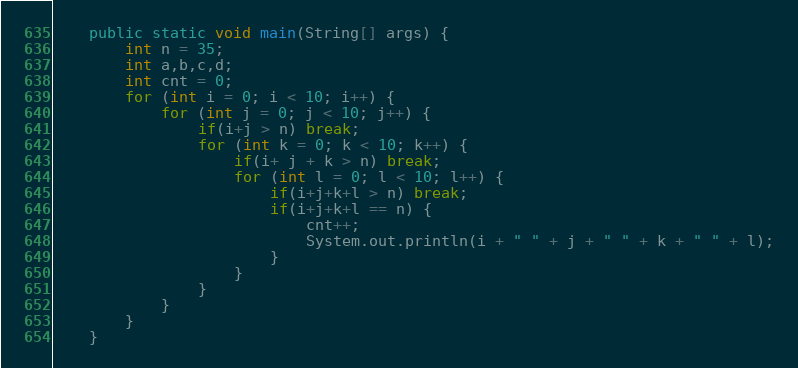Convert code to text. <code><loc_0><loc_0><loc_500><loc_500><_Java_>	public static void main(String[] args) {
		int n = 35;
		int a,b,c,d;
		int cnt = 0;
		for (int i = 0; i < 10; i++) {
			for (int j = 0; j < 10; j++) {
				if(i+j > n) break;
				for (int k = 0; k < 10; k++) {
					if(i+ j + k > n) break;
					for (int l = 0; l < 10; l++) {
						if(i+j+k+l > n) break;
						if(i+j+k+l == n) {
							cnt++;
							System.out.println(i + " " + j + " " + k + " " + l);
						}
					}
				}
			}
		}
	}</code> 